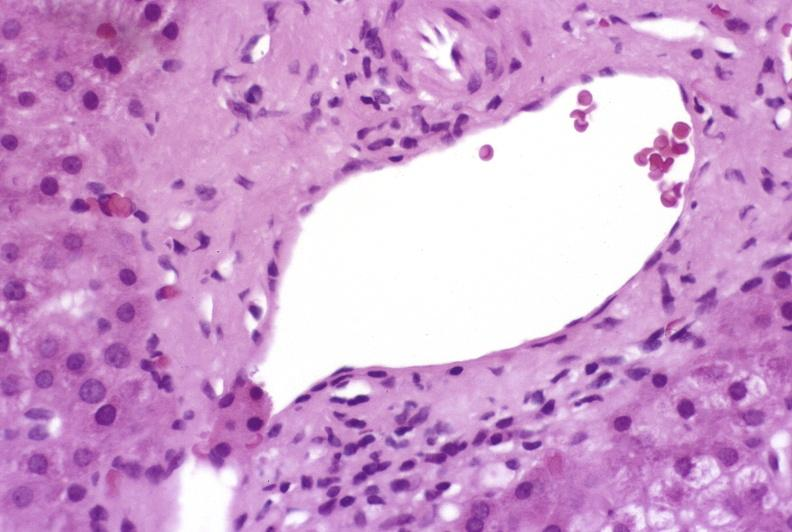s lymphoid atrophy in newborn present?
Answer the question using a single word or phrase. No 